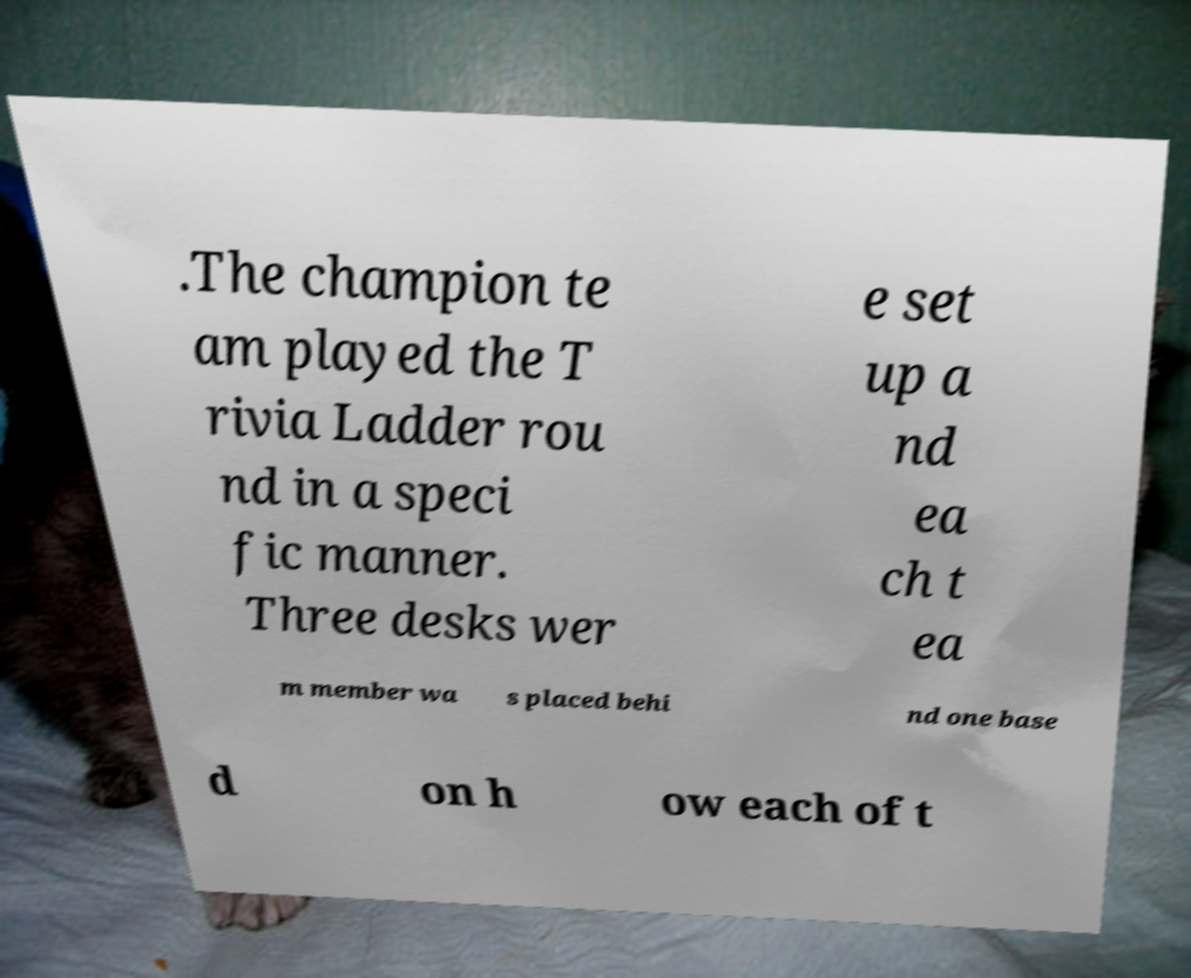I need the written content from this picture converted into text. Can you do that? .The champion te am played the T rivia Ladder rou nd in a speci fic manner. Three desks wer e set up a nd ea ch t ea m member wa s placed behi nd one base d on h ow each of t 